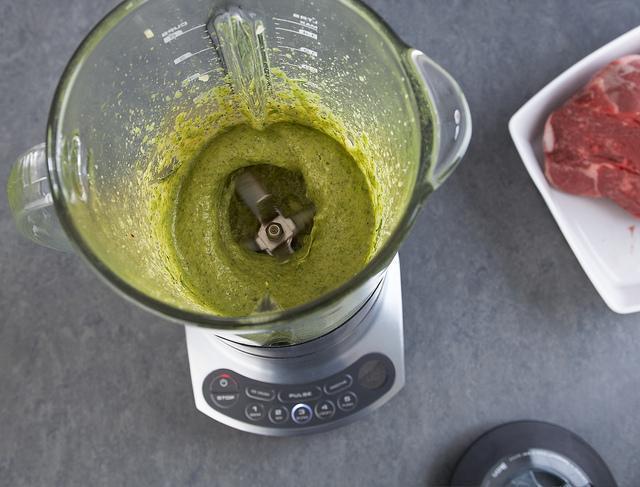How many buttons on the blender?
Give a very brief answer. 9. 